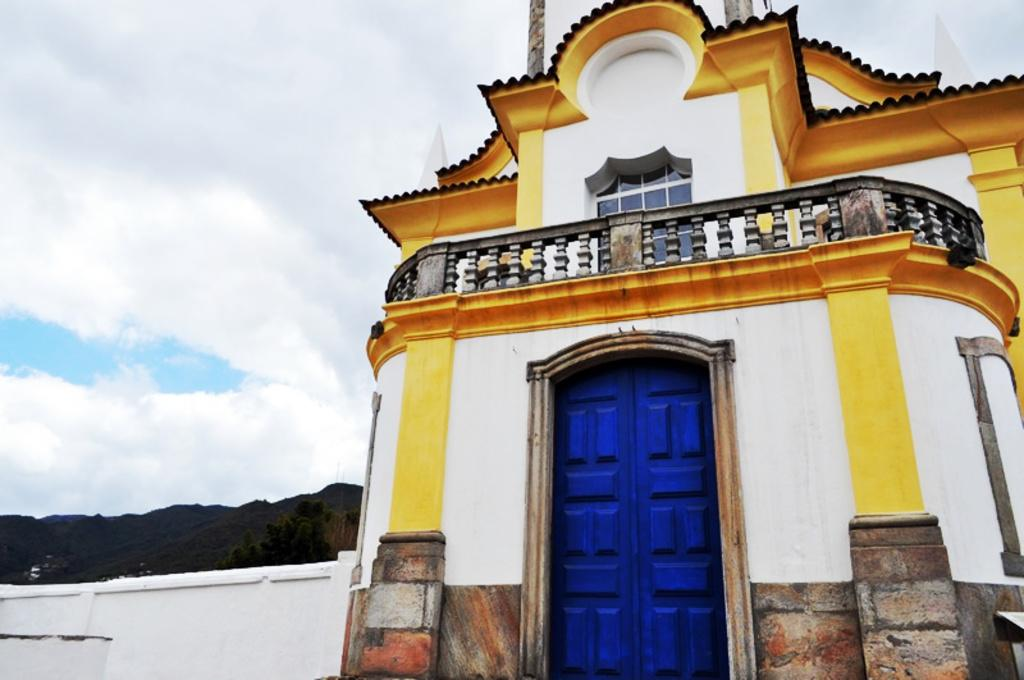What type of structure is present in the image? There is a building in the image. What colors are used on the building? The building has white and yellow colors. What color is the door of the building? The door of the building is in blue color. What can be seen in the left corner of the image? There are mountains in the left corner of the image. How would you describe the sky in the image? The sky is cloudy. What type of ink is used to paint the sky in the image? There is no ink used in the image, as it is a photograph or digital representation of the scene. 